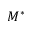<formula> <loc_0><loc_0><loc_500><loc_500>M ^ { * }</formula> 